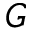Convert formula to latex. <formula><loc_0><loc_0><loc_500><loc_500>G</formula> 